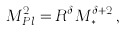Convert formula to latex. <formula><loc_0><loc_0><loc_500><loc_500>M _ { P l } ^ { 2 } = R ^ { \delta } M _ { * } ^ { \delta + 2 } \, ,</formula> 